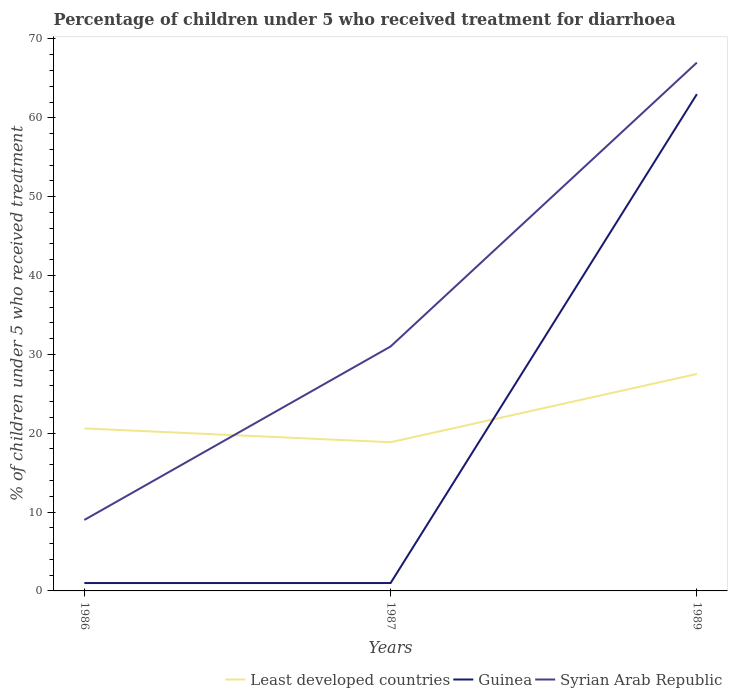Does the line corresponding to Syrian Arab Republic intersect with the line corresponding to Least developed countries?
Keep it short and to the point. Yes. Across all years, what is the maximum percentage of children who received treatment for diarrhoea  in Guinea?
Your answer should be compact. 1. In which year was the percentage of children who received treatment for diarrhoea  in Syrian Arab Republic maximum?
Your answer should be very brief. 1986. What is the total percentage of children who received treatment for diarrhoea  in Guinea in the graph?
Your answer should be compact. -62. Is the percentage of children who received treatment for diarrhoea  in Guinea strictly greater than the percentage of children who received treatment for diarrhoea  in Least developed countries over the years?
Make the answer very short. No. How many lines are there?
Keep it short and to the point. 3. Are the values on the major ticks of Y-axis written in scientific E-notation?
Offer a terse response. No. Where does the legend appear in the graph?
Your response must be concise. Bottom right. How are the legend labels stacked?
Keep it short and to the point. Horizontal. What is the title of the graph?
Offer a terse response. Percentage of children under 5 who received treatment for diarrhoea. What is the label or title of the X-axis?
Make the answer very short. Years. What is the label or title of the Y-axis?
Provide a succinct answer. % of children under 5 who received treatment. What is the % of children under 5 who received treatment of Least developed countries in 1986?
Provide a short and direct response. 20.61. What is the % of children under 5 who received treatment in Syrian Arab Republic in 1986?
Provide a short and direct response. 9. What is the % of children under 5 who received treatment in Least developed countries in 1987?
Your answer should be compact. 18.86. What is the % of children under 5 who received treatment in Guinea in 1987?
Provide a short and direct response. 1. What is the % of children under 5 who received treatment of Syrian Arab Republic in 1987?
Keep it short and to the point. 31. What is the % of children under 5 who received treatment in Least developed countries in 1989?
Provide a succinct answer. 27.51. Across all years, what is the maximum % of children under 5 who received treatment in Least developed countries?
Keep it short and to the point. 27.51. Across all years, what is the maximum % of children under 5 who received treatment of Guinea?
Provide a short and direct response. 63. Across all years, what is the maximum % of children under 5 who received treatment of Syrian Arab Republic?
Make the answer very short. 67. Across all years, what is the minimum % of children under 5 who received treatment of Least developed countries?
Provide a succinct answer. 18.86. Across all years, what is the minimum % of children under 5 who received treatment in Guinea?
Keep it short and to the point. 1. Across all years, what is the minimum % of children under 5 who received treatment in Syrian Arab Republic?
Give a very brief answer. 9. What is the total % of children under 5 who received treatment in Least developed countries in the graph?
Offer a very short reply. 66.98. What is the total % of children under 5 who received treatment in Syrian Arab Republic in the graph?
Your answer should be compact. 107. What is the difference between the % of children under 5 who received treatment in Least developed countries in 1986 and that in 1987?
Ensure brevity in your answer.  1.75. What is the difference between the % of children under 5 who received treatment of Guinea in 1986 and that in 1987?
Provide a succinct answer. 0. What is the difference between the % of children under 5 who received treatment in Syrian Arab Republic in 1986 and that in 1987?
Your answer should be very brief. -22. What is the difference between the % of children under 5 who received treatment in Least developed countries in 1986 and that in 1989?
Your answer should be very brief. -6.9. What is the difference between the % of children under 5 who received treatment of Guinea in 1986 and that in 1989?
Offer a very short reply. -62. What is the difference between the % of children under 5 who received treatment in Syrian Arab Republic in 1986 and that in 1989?
Provide a succinct answer. -58. What is the difference between the % of children under 5 who received treatment of Least developed countries in 1987 and that in 1989?
Give a very brief answer. -8.65. What is the difference between the % of children under 5 who received treatment of Guinea in 1987 and that in 1989?
Your answer should be compact. -62. What is the difference between the % of children under 5 who received treatment in Syrian Arab Republic in 1987 and that in 1989?
Keep it short and to the point. -36. What is the difference between the % of children under 5 who received treatment in Least developed countries in 1986 and the % of children under 5 who received treatment in Guinea in 1987?
Offer a very short reply. 19.61. What is the difference between the % of children under 5 who received treatment in Least developed countries in 1986 and the % of children under 5 who received treatment in Syrian Arab Republic in 1987?
Give a very brief answer. -10.39. What is the difference between the % of children under 5 who received treatment in Least developed countries in 1986 and the % of children under 5 who received treatment in Guinea in 1989?
Keep it short and to the point. -42.39. What is the difference between the % of children under 5 who received treatment of Least developed countries in 1986 and the % of children under 5 who received treatment of Syrian Arab Republic in 1989?
Ensure brevity in your answer.  -46.39. What is the difference between the % of children under 5 who received treatment in Guinea in 1986 and the % of children under 5 who received treatment in Syrian Arab Republic in 1989?
Your answer should be compact. -66. What is the difference between the % of children under 5 who received treatment of Least developed countries in 1987 and the % of children under 5 who received treatment of Guinea in 1989?
Your answer should be very brief. -44.14. What is the difference between the % of children under 5 who received treatment in Least developed countries in 1987 and the % of children under 5 who received treatment in Syrian Arab Republic in 1989?
Offer a very short reply. -48.14. What is the difference between the % of children under 5 who received treatment of Guinea in 1987 and the % of children under 5 who received treatment of Syrian Arab Republic in 1989?
Give a very brief answer. -66. What is the average % of children under 5 who received treatment in Least developed countries per year?
Give a very brief answer. 22.33. What is the average % of children under 5 who received treatment of Guinea per year?
Keep it short and to the point. 21.67. What is the average % of children under 5 who received treatment of Syrian Arab Republic per year?
Give a very brief answer. 35.67. In the year 1986, what is the difference between the % of children under 5 who received treatment in Least developed countries and % of children under 5 who received treatment in Guinea?
Make the answer very short. 19.61. In the year 1986, what is the difference between the % of children under 5 who received treatment in Least developed countries and % of children under 5 who received treatment in Syrian Arab Republic?
Your answer should be very brief. 11.61. In the year 1986, what is the difference between the % of children under 5 who received treatment in Guinea and % of children under 5 who received treatment in Syrian Arab Republic?
Offer a terse response. -8. In the year 1987, what is the difference between the % of children under 5 who received treatment of Least developed countries and % of children under 5 who received treatment of Guinea?
Provide a succinct answer. 17.86. In the year 1987, what is the difference between the % of children under 5 who received treatment of Least developed countries and % of children under 5 who received treatment of Syrian Arab Republic?
Ensure brevity in your answer.  -12.14. In the year 1987, what is the difference between the % of children under 5 who received treatment of Guinea and % of children under 5 who received treatment of Syrian Arab Republic?
Offer a very short reply. -30. In the year 1989, what is the difference between the % of children under 5 who received treatment in Least developed countries and % of children under 5 who received treatment in Guinea?
Provide a succinct answer. -35.49. In the year 1989, what is the difference between the % of children under 5 who received treatment of Least developed countries and % of children under 5 who received treatment of Syrian Arab Republic?
Ensure brevity in your answer.  -39.49. What is the ratio of the % of children under 5 who received treatment of Least developed countries in 1986 to that in 1987?
Provide a short and direct response. 1.09. What is the ratio of the % of children under 5 who received treatment of Syrian Arab Republic in 1986 to that in 1987?
Offer a very short reply. 0.29. What is the ratio of the % of children under 5 who received treatment in Least developed countries in 1986 to that in 1989?
Provide a succinct answer. 0.75. What is the ratio of the % of children under 5 who received treatment of Guinea in 1986 to that in 1989?
Your answer should be compact. 0.02. What is the ratio of the % of children under 5 who received treatment in Syrian Arab Republic in 1986 to that in 1989?
Provide a succinct answer. 0.13. What is the ratio of the % of children under 5 who received treatment of Least developed countries in 1987 to that in 1989?
Provide a short and direct response. 0.69. What is the ratio of the % of children under 5 who received treatment in Guinea in 1987 to that in 1989?
Give a very brief answer. 0.02. What is the ratio of the % of children under 5 who received treatment of Syrian Arab Republic in 1987 to that in 1989?
Your answer should be compact. 0.46. What is the difference between the highest and the second highest % of children under 5 who received treatment in Least developed countries?
Ensure brevity in your answer.  6.9. What is the difference between the highest and the second highest % of children under 5 who received treatment of Syrian Arab Republic?
Provide a short and direct response. 36. What is the difference between the highest and the lowest % of children under 5 who received treatment in Least developed countries?
Offer a terse response. 8.65. What is the difference between the highest and the lowest % of children under 5 who received treatment of Guinea?
Your answer should be very brief. 62. What is the difference between the highest and the lowest % of children under 5 who received treatment of Syrian Arab Republic?
Your response must be concise. 58. 